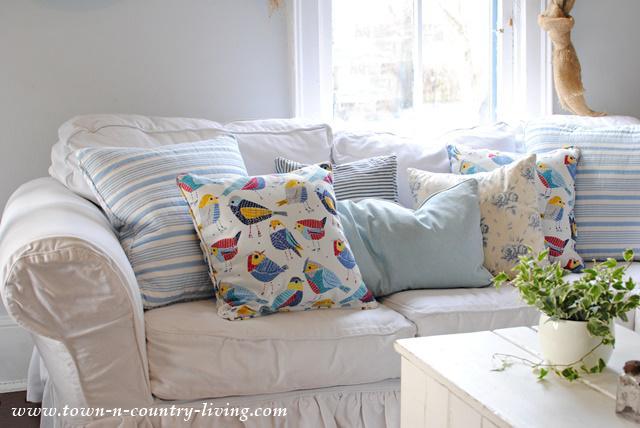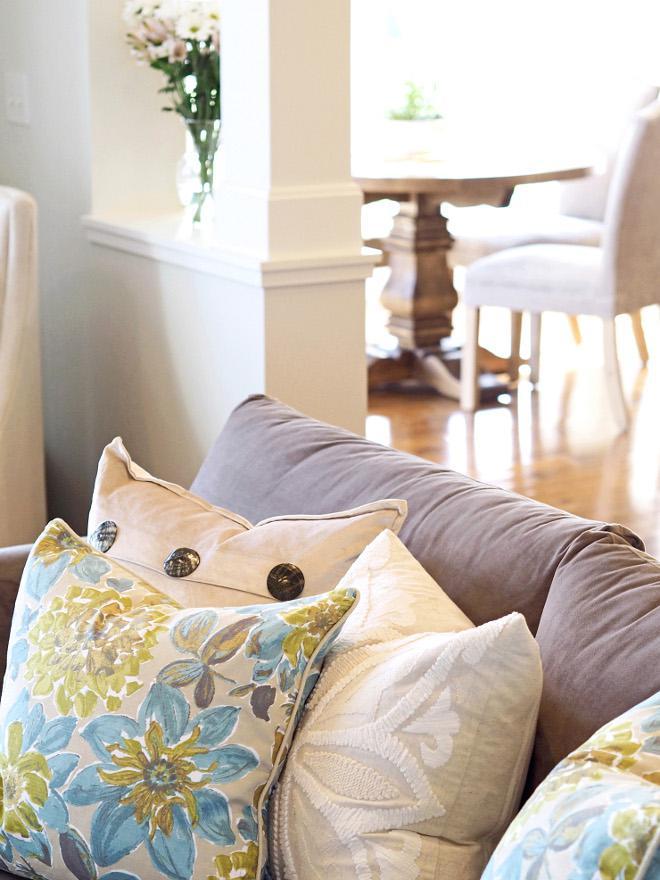The first image is the image on the left, the second image is the image on the right. Examine the images to the left and right. Is the description "One image includes a square pale pillow with a horizontal row of at least three buttons, and the other image features multiple pillows on a white couch, including pillows with all-over picture prints." accurate? Answer yes or no. Yes. The first image is the image on the left, the second image is the image on the right. Given the left and right images, does the statement "In at least one image there is a single knitted pillow with a afghan on top of a sofa chair." hold true? Answer yes or no. No. 